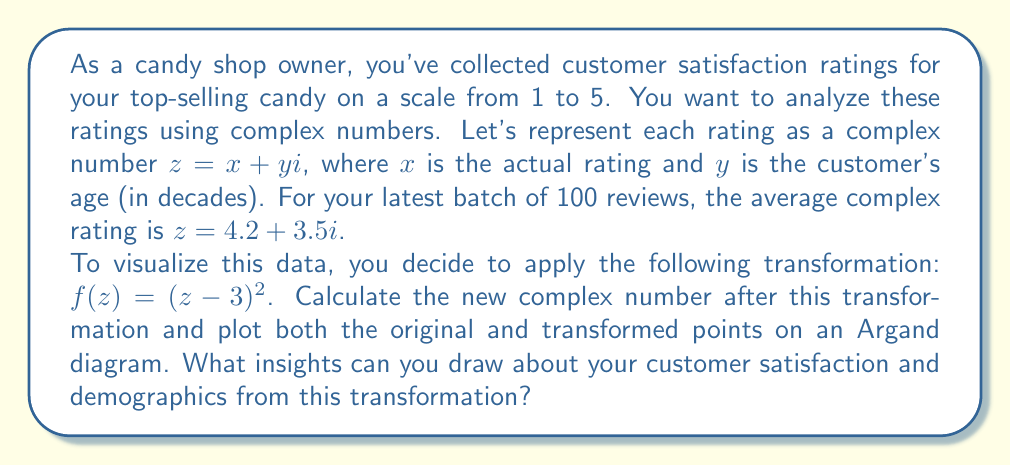Show me your answer to this math problem. Let's approach this step-by-step:

1) We start with the average complex rating $z = 4.2 + 3.5i$

2) The transformation we need to apply is $f(z) = (z-3)^2$

3) Let's calculate $f(z)$:
   
   $f(z) = (z-3)^2 = ((4.2 + 3.5i) - 3)^2 = (1.2 + 3.5i)^2$

4) To square a complex number $a+bi$, we use the formula $(a+bi)^2 = (a^2-b^2) + (2ab)i$

   So, $(1.2 + 3.5i)^2 = (1.2^2 - 3.5^2) + (2 * 1.2 * 3.5)i$
                       $= (1.44 - 12.25) + 8.4i$
                       $= -10.81 + 8.4i$

5) Now, let's plot both the original point (4.2, 3.5) and the transformed point (-10.81, 8.4) on an Argand diagram:

   [asy]
   import graph;
   size(200);
   
   xaxis("Re", arrow=Arrow);
   yaxis("Im", arrow=Arrow);
   
   dot((4.2,3.5), red);
   dot((-10.81,8.4), blue);
   
   label("Original", (4.2,3.5), E, red);
   label("Transformed", (-10.81,8.4), N, blue);
   
   draw((0,0)--(4.2,3.5), red+dashed);
   draw((0,0)--(-10.81,8.4), blue+dashed);
   [/asy]

6) Insights from this transformation:
   - The original point (4.2, 3.5) indicates a high average rating (4.2 out of 5) and an average customer age of 35 years.
   - The transformation amplifies differences from the midpoint rating (3). Since our original rating was above average, the transformed point moves further from the origin.
   - The imaginary component (representing age) has increased more dramatically than the real component (representing rating), suggesting that age differences may be a more significant factor in your customer base than rating differences.
   - The negative real part of the transformed point (-10.81) doesn't represent a negative rating, but rather reflects how the transformation exaggerates the distance from the midpoint rating.
Answer: The transformed complex number is $-10.81 + 8.4i$. This transformation highlights that your candy shop has above-average ratings (4.2 out of 5) and suggests a significant middle-aged customer base (average age 35). The amplification of the age component in the transformation indicates that your shop might benefit from strategies tailored to this age group, while also considering how to attract a broader age range of customers. 